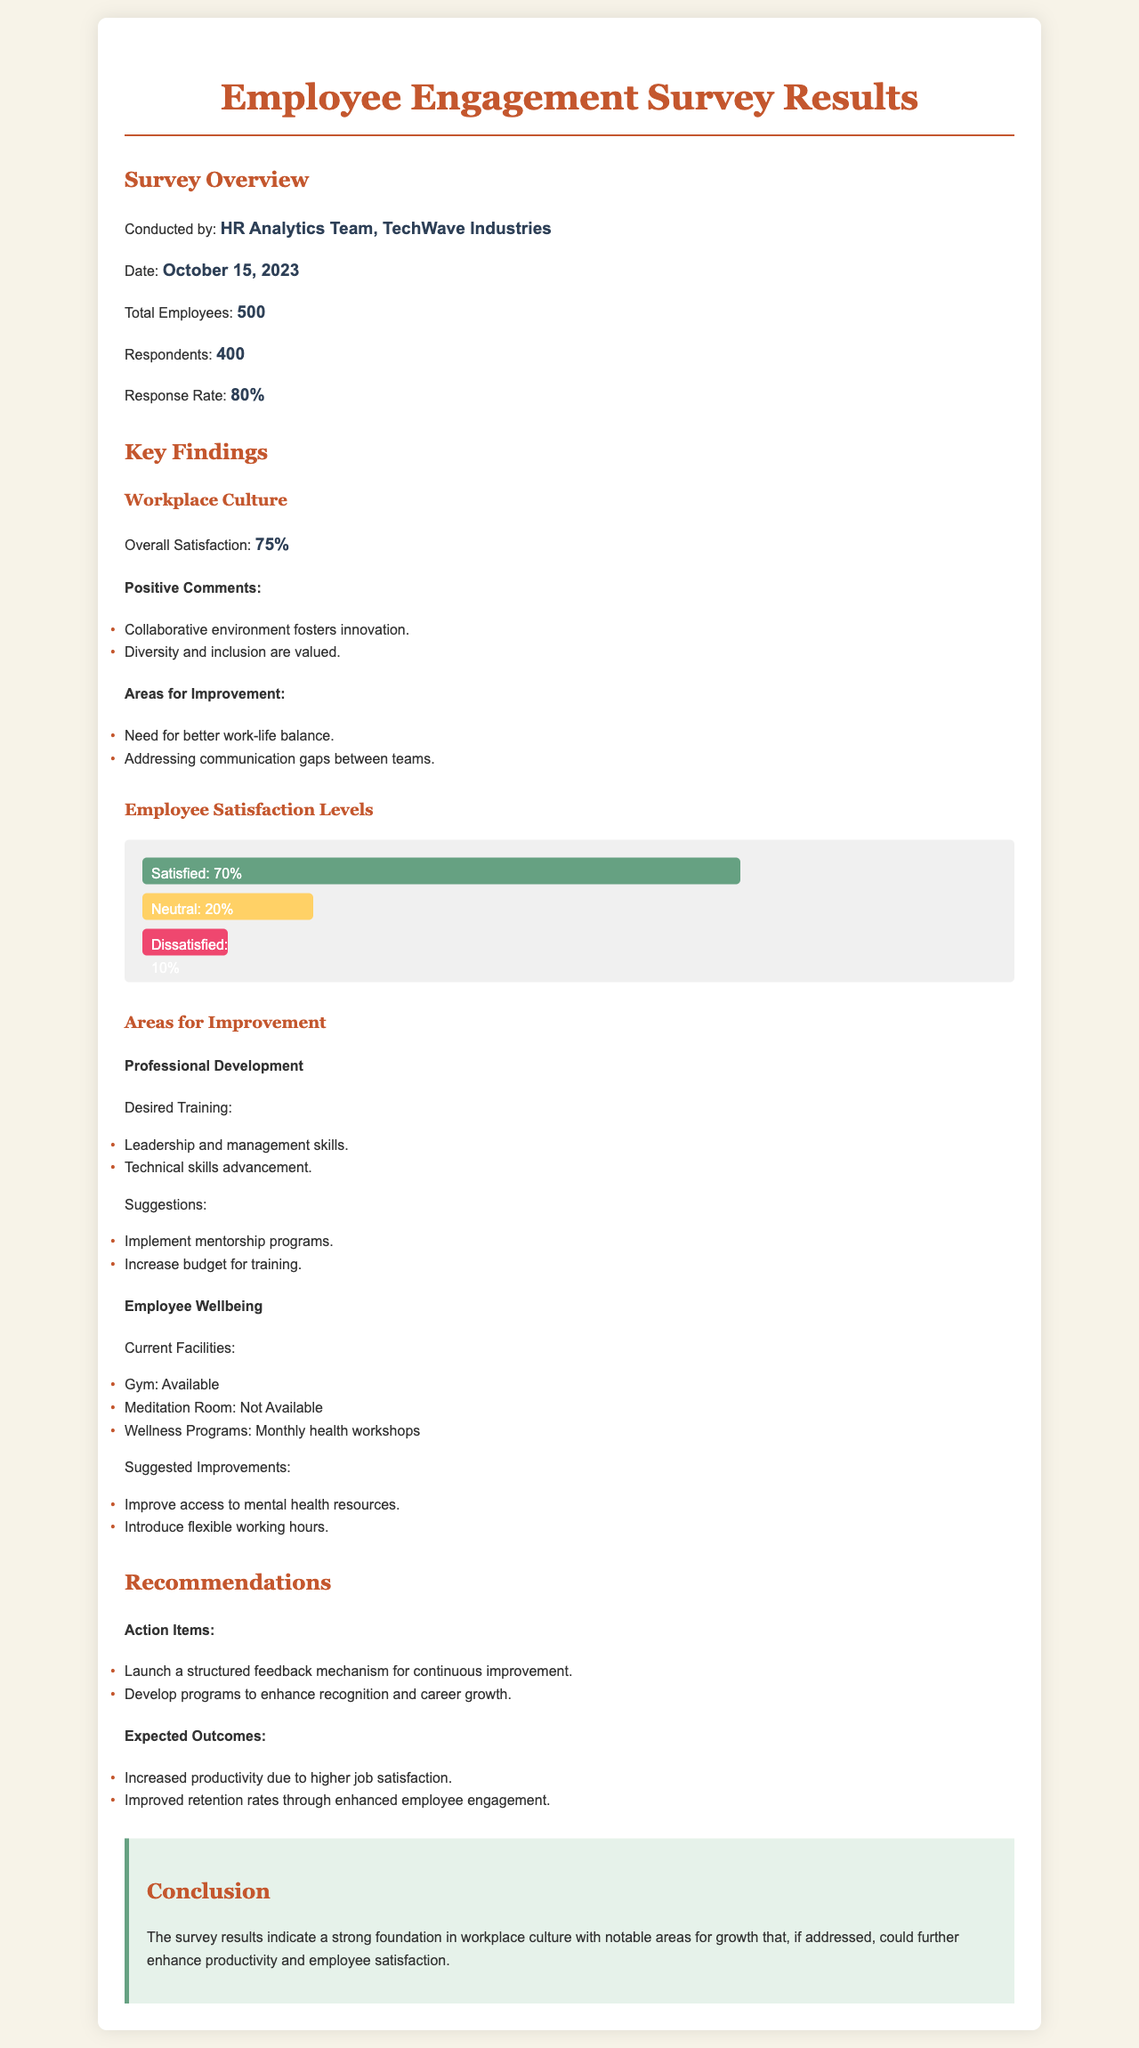What was the overall satisfaction percentage reported? The overall satisfaction percentage reported is 75%.
Answer: 75% Who conducted the survey? The survey was conducted by the HR Analytics Team, TechWave Industries.
Answer: HR Analytics Team, TechWave Industries What percentage of employees responded to the survey? The percentage of employees who responded to the survey is 80%.
Answer: 80% What is one suggested improvement for employee wellbeing? One suggested improvement for employee wellbeing is to improve access to mental health resources.
Answer: Improve access to mental health resources What are two areas identified for professional development? The two areas identified for professional development are leadership and management skills, and technical skills advancement.
Answer: Leadership and management skills, technical skills advancement What is the current satisfaction level of employees? The current satisfaction level of employees is 70%.
Answer: 70% What action item is recommended regarding feedback? The recommended action item regarding feedback is to launch a structured feedback mechanism for continuous improvement.
Answer: Launch a structured feedback mechanism for continuous improvement What is one expected outcome of the recommendations? One expected outcome of the recommendations is increased productivity due to higher job satisfaction.
Answer: Increased productivity due to higher job satisfaction What is the date the survey was conducted? The survey was conducted on October 15, 2023.
Answer: October 15, 2023 